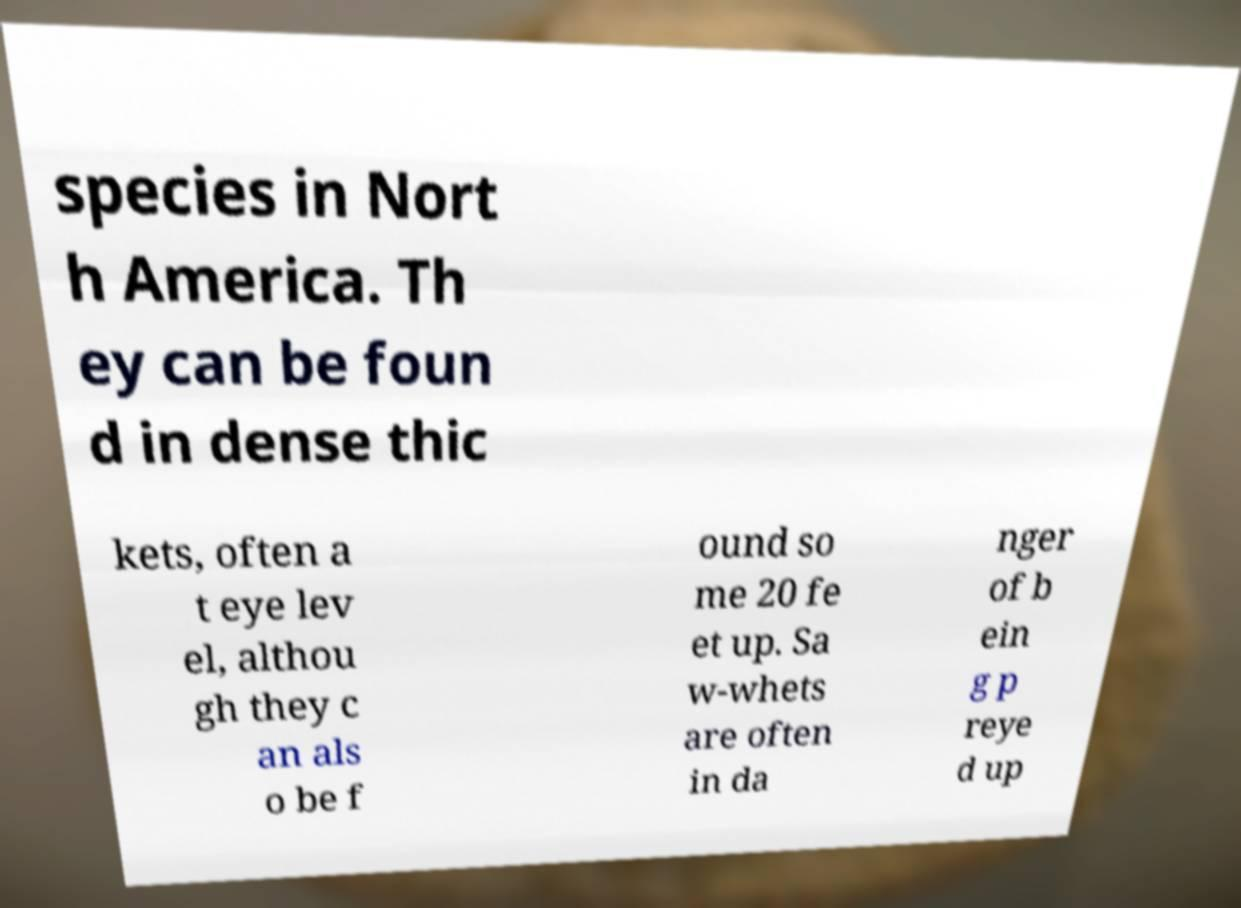Please read and relay the text visible in this image. What does it say? species in Nort h America. Th ey can be foun d in dense thic kets, often a t eye lev el, althou gh they c an als o be f ound so me 20 fe et up. Sa w-whets are often in da nger of b ein g p reye d up 